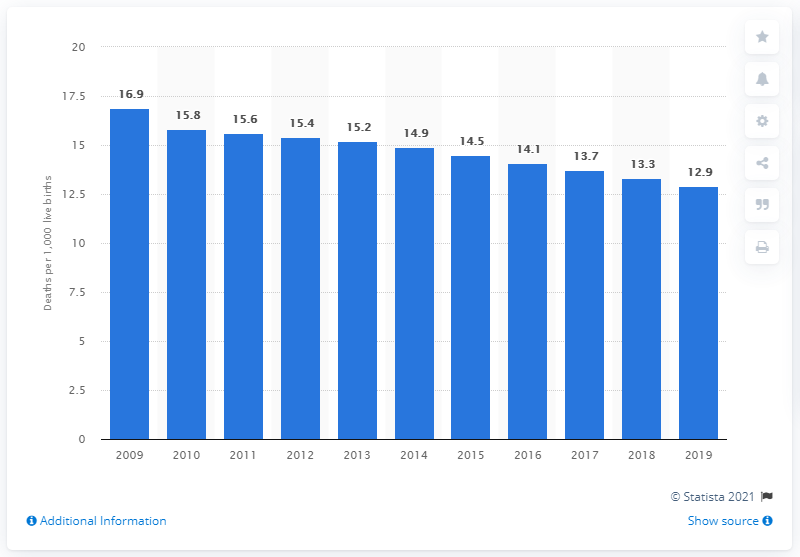Mention a couple of crucial points in this snapshot. In 2019, the infant mortality rate in Samoa was 12.9. 